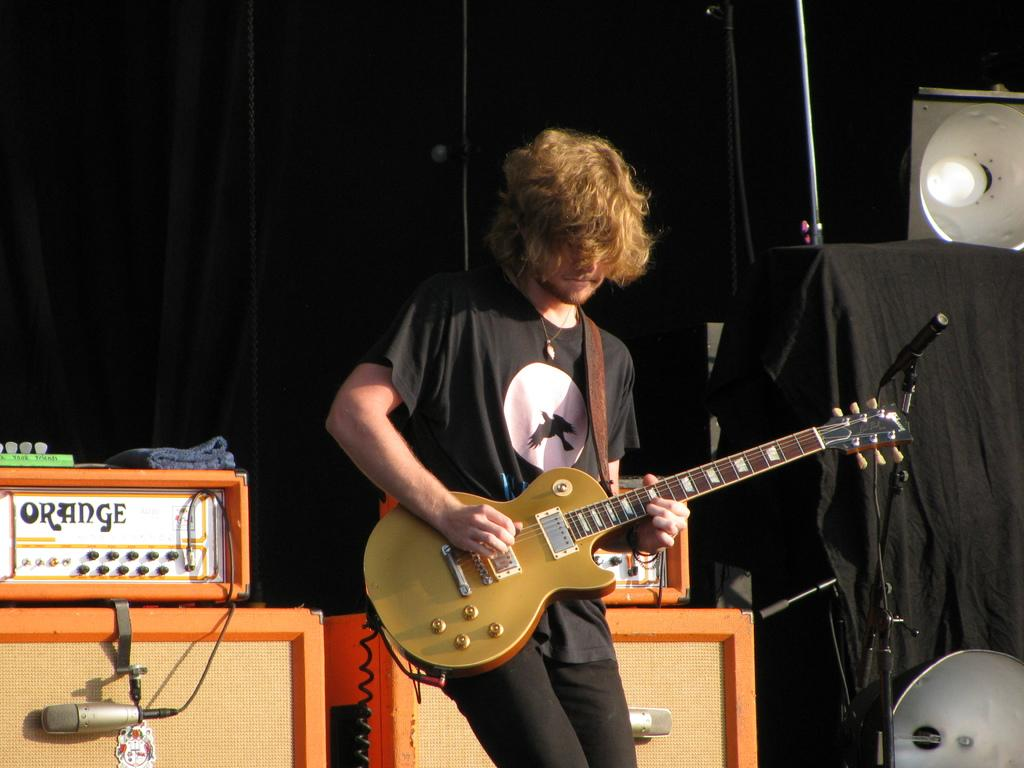What is the color of the background in the image? The background of the image is dark. Who is present in the image? There is a man in the image. What is the man wearing? The man is wearing a black t-shirt. What is the man doing in the image? The man is playing a guitar. What other objects can be seen in the image? There are electronic devices in the image. How many apples are on the table in the image? There are no apples present in the image. What type of care does the man provide for the electronic devices in the image? There is no indication of the man providing care for the electronic devices in the image. 